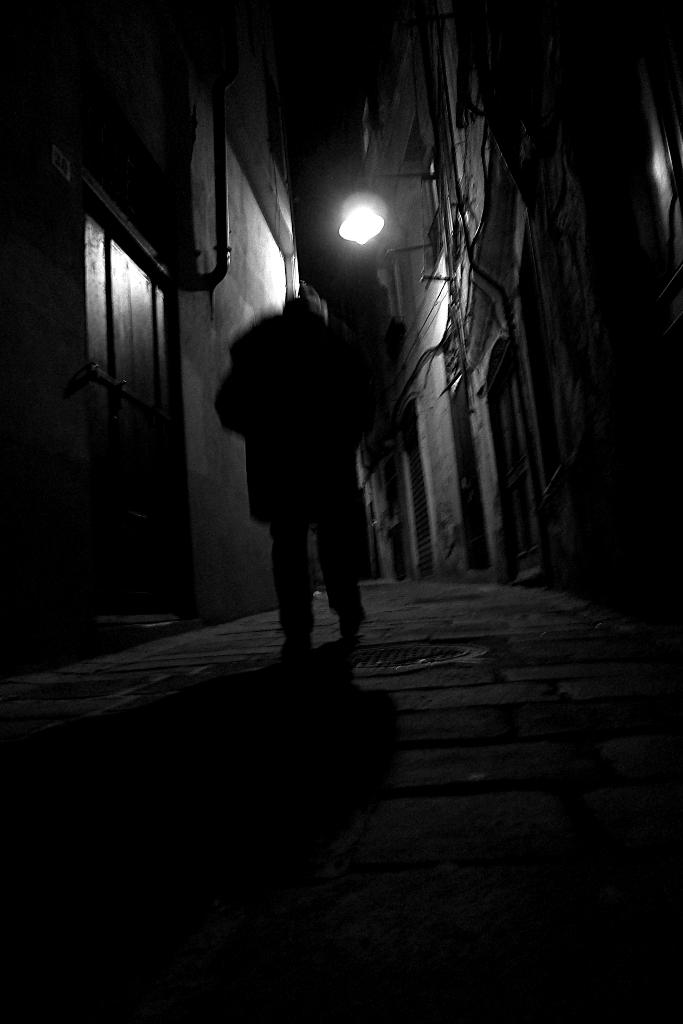What is the person in the image doing? The person is walking in the image. Where is the person walking? The person is walking on a street. What can be seen on both sides of the street? There are buildings on both sides of the street. Is there any lighting source visible in the image? Yes, there is a light attached to one of the buildings. Can you tell me how many bears are walking with the person in the image? There are no bears present in the image; only a person walking on a street is visible. Is there any indication that the person is about to kiss someone in the image? There is no indication of a kiss or any romantic interaction in the image. 